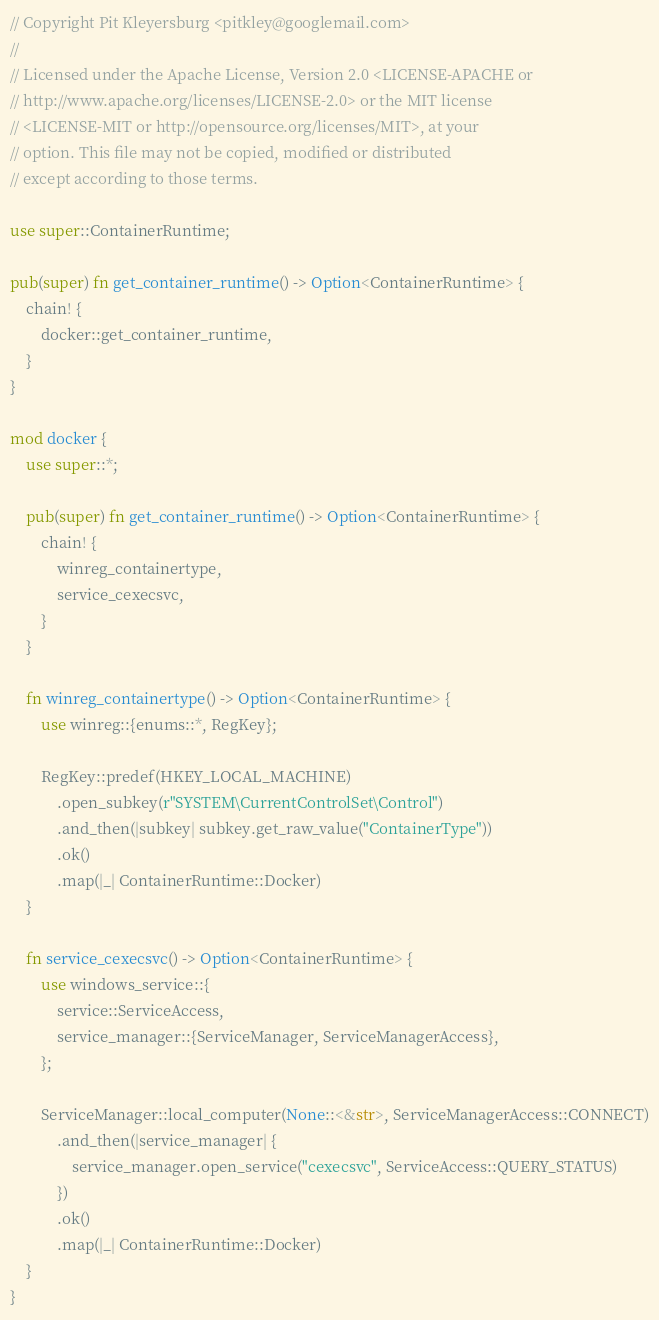<code> <loc_0><loc_0><loc_500><loc_500><_Rust_>// Copyright Pit Kleyersburg <pitkley@googlemail.com>
//
// Licensed under the Apache License, Version 2.0 <LICENSE-APACHE or
// http://www.apache.org/licenses/LICENSE-2.0> or the MIT license
// <LICENSE-MIT or http://opensource.org/licenses/MIT>, at your
// option. This file may not be copied, modified or distributed
// except according to those terms.

use super::ContainerRuntime;

pub(super) fn get_container_runtime() -> Option<ContainerRuntime> {
    chain! {
        docker::get_container_runtime,
    }
}

mod docker {
    use super::*;

    pub(super) fn get_container_runtime() -> Option<ContainerRuntime> {
        chain! {
            winreg_containertype,
            service_cexecsvc,
        }
    }

    fn winreg_containertype() -> Option<ContainerRuntime> {
        use winreg::{enums::*, RegKey};

        RegKey::predef(HKEY_LOCAL_MACHINE)
            .open_subkey(r"SYSTEM\CurrentControlSet\Control")
            .and_then(|subkey| subkey.get_raw_value("ContainerType"))
            .ok()
            .map(|_| ContainerRuntime::Docker)
    }

    fn service_cexecsvc() -> Option<ContainerRuntime> {
        use windows_service::{
            service::ServiceAccess,
            service_manager::{ServiceManager, ServiceManagerAccess},
        };

        ServiceManager::local_computer(None::<&str>, ServiceManagerAccess::CONNECT)
            .and_then(|service_manager| {
                service_manager.open_service("cexecsvc", ServiceAccess::QUERY_STATUS)
            })
            .ok()
            .map(|_| ContainerRuntime::Docker)
    }
}
</code> 